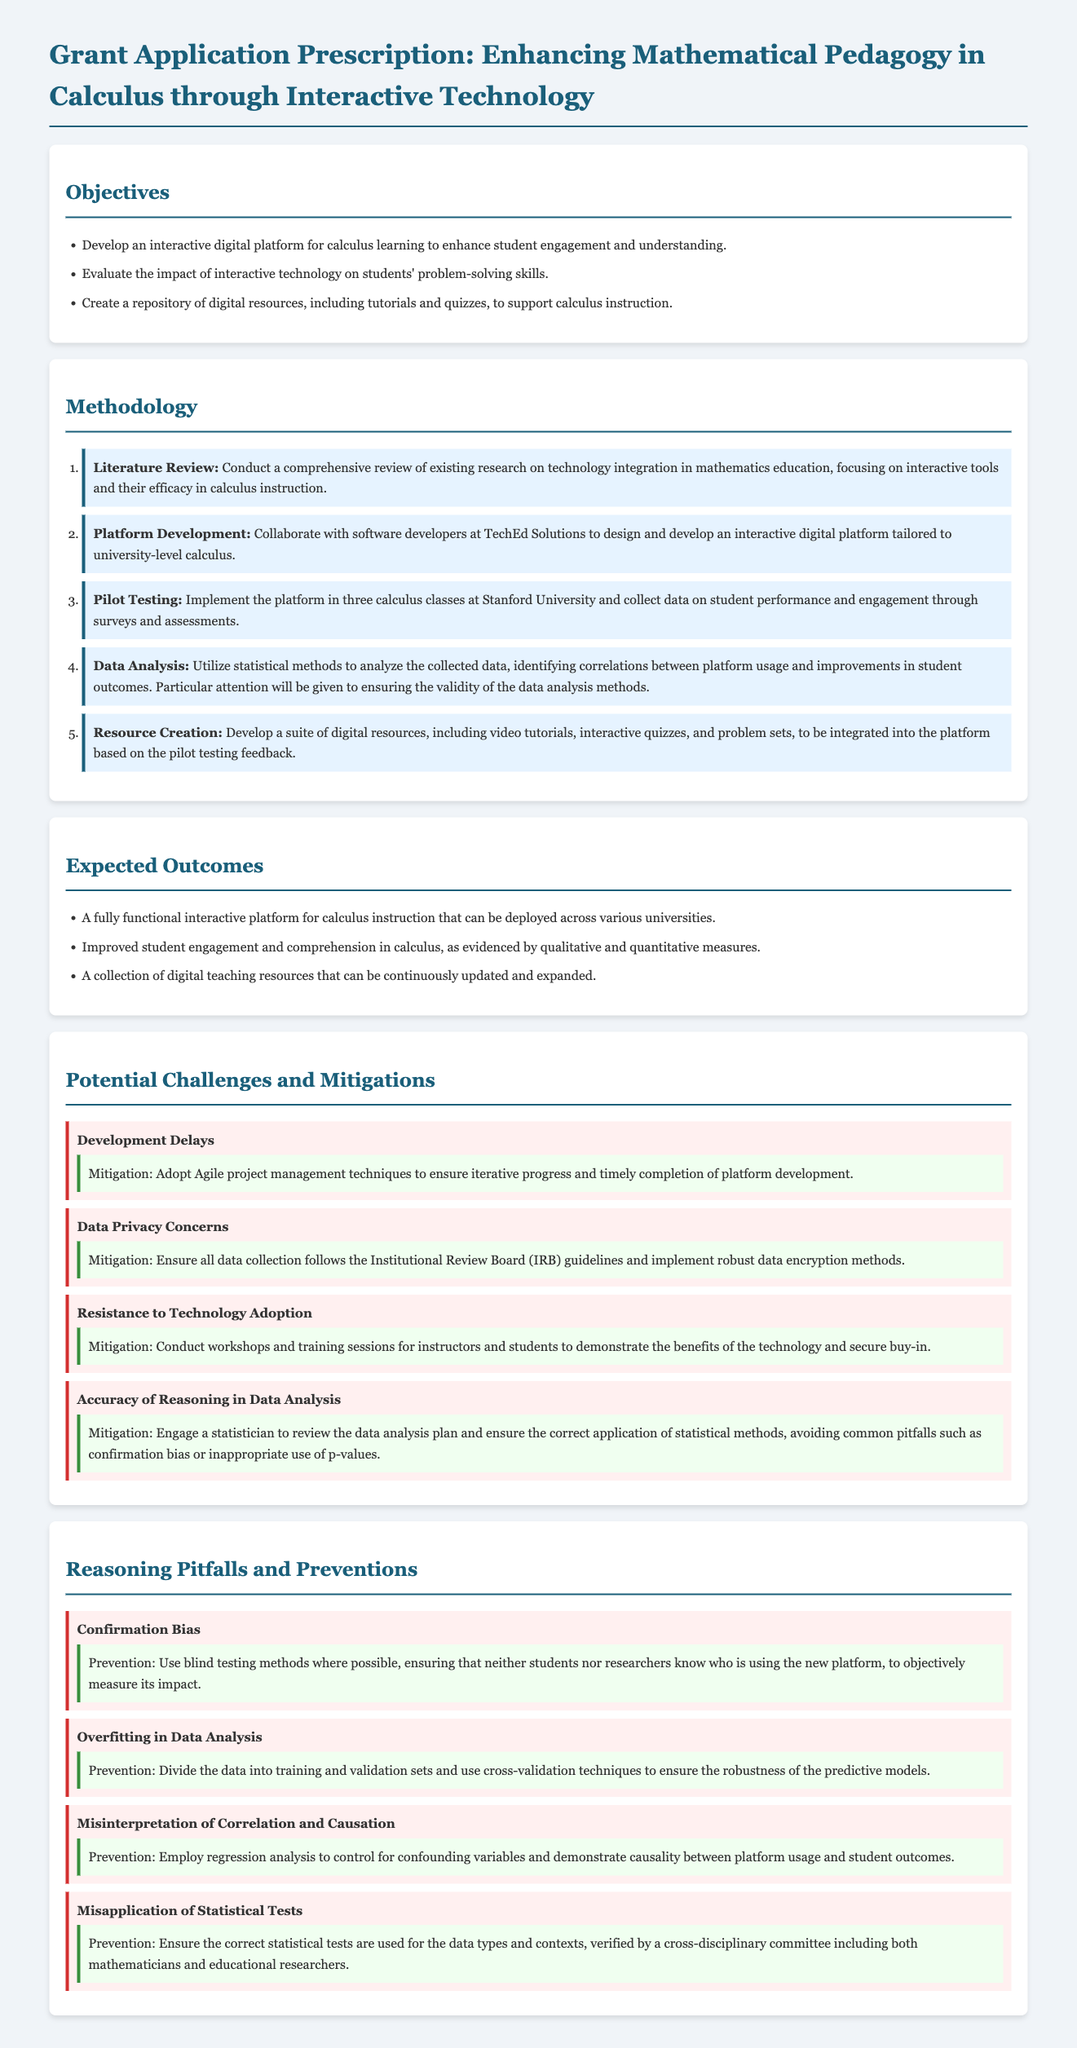What is the main title of the grant proposal? The main title of the grant proposal is stated in the header of the document.
Answer: Enhancing Mathematical Pedagogy in Calculus through Interactive Technology How many objectives are listed in the proposal? The number of objectives is found by counting the items in the Objectives section.
Answer: Three What technique is suggested to mitigate development delays? The proposed mitigation technique is outlined under the Challenges section.
Answer: Agile project management techniques What specific aspect of data analysis is mentioned as a potential challenge? The potential challenges discussed will be found in the section addressing challenges.
Answer: Accuracy of Reasoning in Data Analysis Which method is recommended to prevent confirmation bias? The prevention method for confirmation bias is described in the Reasoning Pitfalls section.
Answer: Use blind testing methods What is one of the expected outcomes of the project? Expected outcomes are listed in the corresponding section of the document.
Answer: A fully functional interactive platform for calculus instruction What should be engaged to review the data analysis plan? This information is stated in the Potential Challenges section mentioning consultation for data analysis.
Answer: A statistician What is the main focus of the literature review? The focus of the literature review is specified in the Methodology section's first step.
Answer: Technology integration in mathematics education 